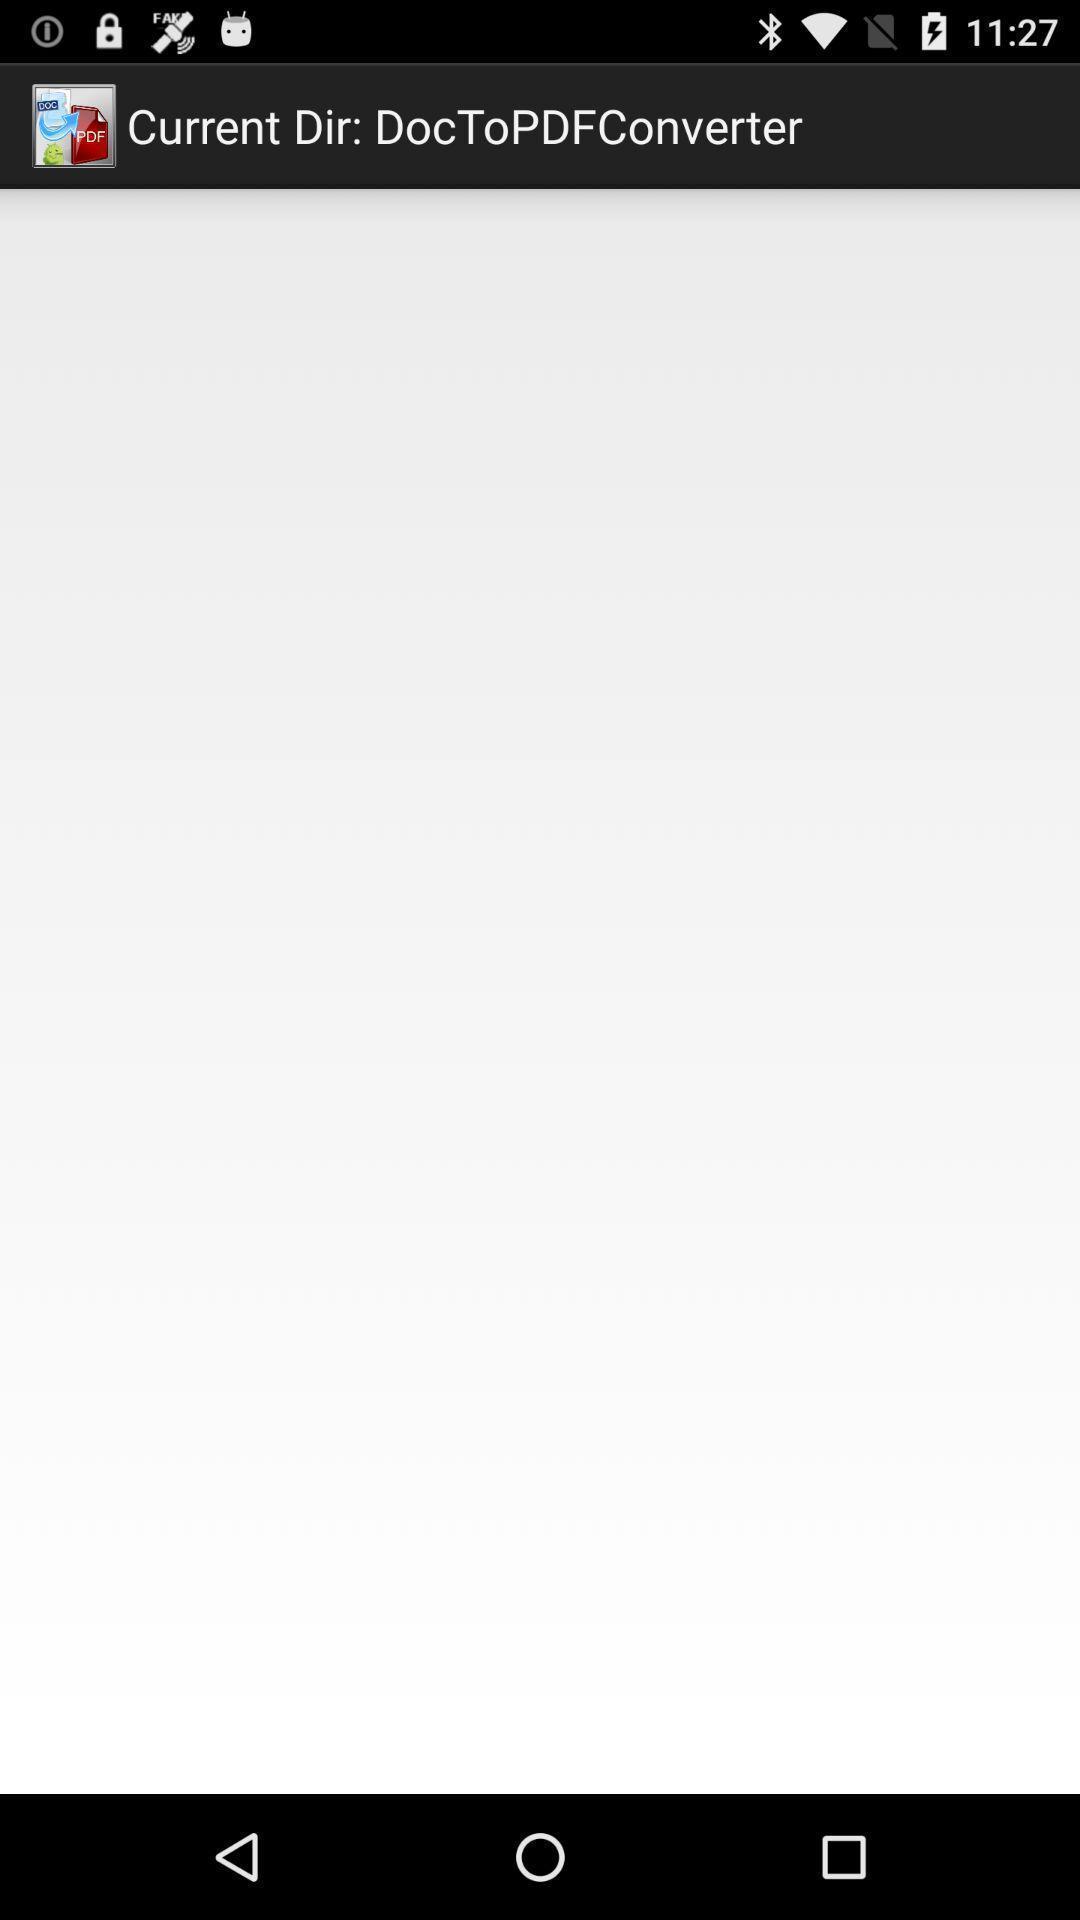Tell me what you see in this picture. Screen displaying the page of pdf converter app. 